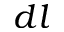Convert formula to latex. <formula><loc_0><loc_0><loc_500><loc_500>d l</formula> 